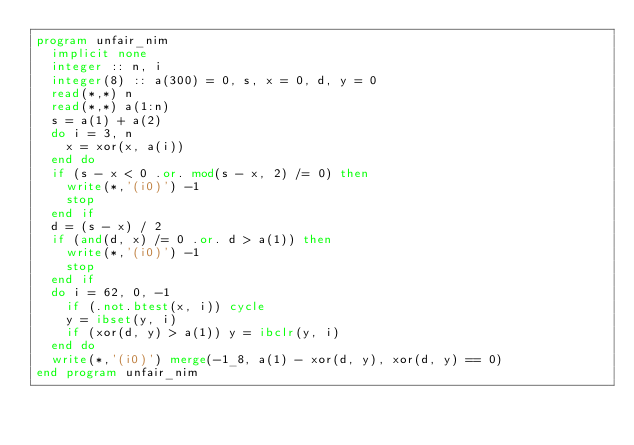Convert code to text. <code><loc_0><loc_0><loc_500><loc_500><_FORTRAN_>program unfair_nim
  implicit none
  integer :: n, i
  integer(8) :: a(300) = 0, s, x = 0, d, y = 0
  read(*,*) n
  read(*,*) a(1:n)
  s = a(1) + a(2)
  do i = 3, n
    x = xor(x, a(i))
  end do
  if (s - x < 0 .or. mod(s - x, 2) /= 0) then
    write(*,'(i0)') -1
    stop
  end if
  d = (s - x) / 2
  if (and(d, x) /= 0 .or. d > a(1)) then
    write(*,'(i0)') -1
    stop
  end if
  do i = 62, 0, -1
    if (.not.btest(x, i)) cycle
    y = ibset(y, i)
    if (xor(d, y) > a(1)) y = ibclr(y, i)
  end do
  write(*,'(i0)') merge(-1_8, a(1) - xor(d, y), xor(d, y) == 0)
end program unfair_nim</code> 